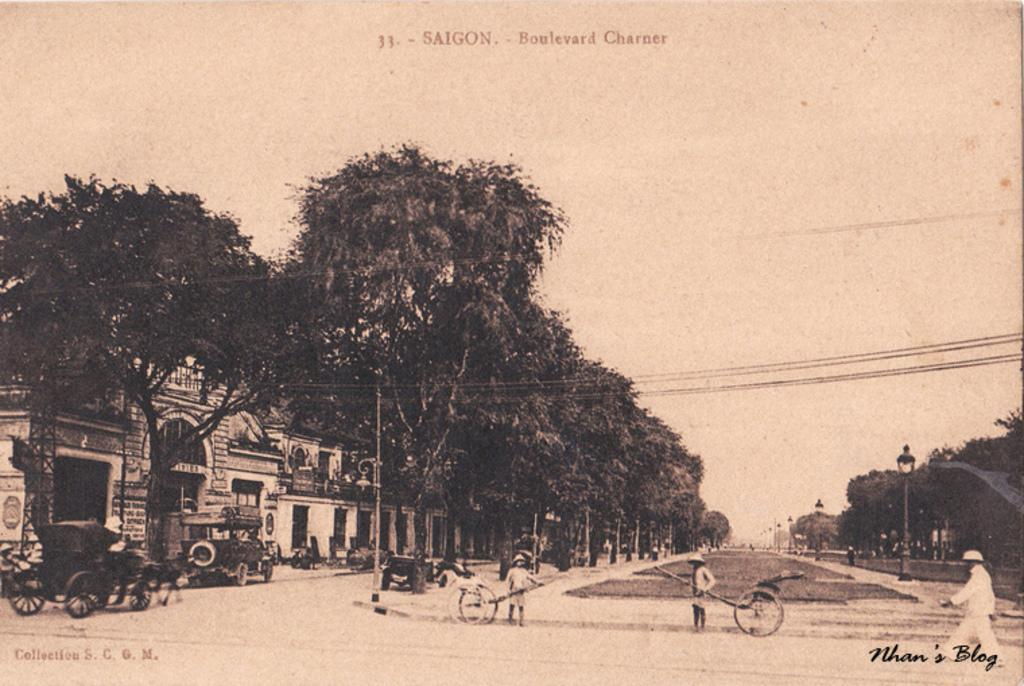What are the people in the image doing? The people in the image are walking. What else can be seen on the road in the image? There are vehicles on the road in the image. What structures are visible in the image? There are buildings visible in the image. What type of vegetation can be seen in the image? There are trees in the image. Where is the box of humor located in the image? There is no box of humor present in the image. Is there a hospital visible in the image? There is no hospital visible in the image. 